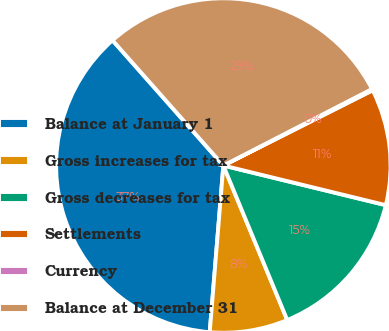Convert chart to OTSL. <chart><loc_0><loc_0><loc_500><loc_500><pie_chart><fcel>Balance at January 1<fcel>Gross increases for tax<fcel>Gross decreases for tax<fcel>Settlements<fcel>Currency<fcel>Balance at December 31<nl><fcel>37.17%<fcel>7.54%<fcel>14.95%<fcel>11.24%<fcel>0.13%<fcel>28.97%<nl></chart> 